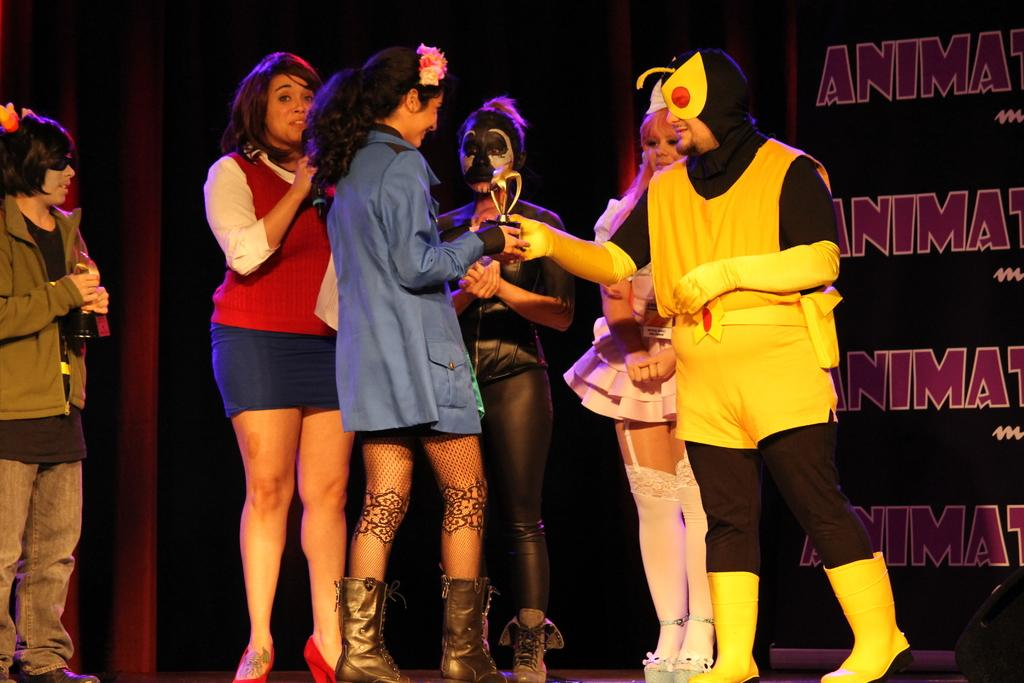How many people are in the image? There are six persons in the image. What are some of the people wearing? Three of the persons are wearing costumes. What is the woman holding in the image? The woman is holding a microphone. What can be seen in the background of the image? There is a banner visible in the image. What letter is the woman spelling out with her face in the image? There is no indication in the image that the woman is spelling out a letter with her face. 